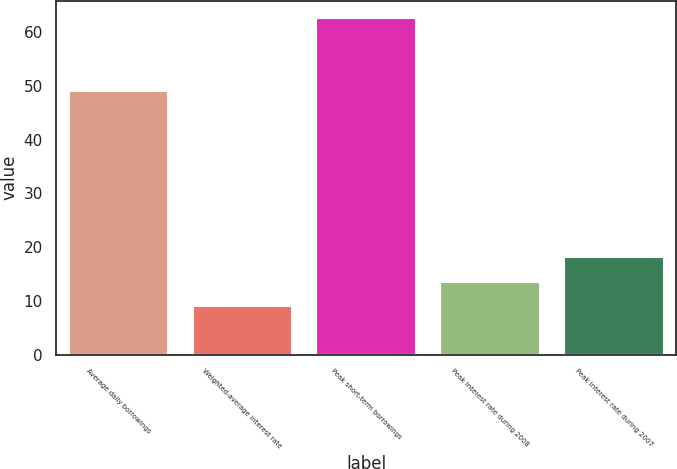<chart> <loc_0><loc_0><loc_500><loc_500><bar_chart><fcel>Average daily borrowings<fcel>Weighted-average interest rate<fcel>Peak short-term borrowings<fcel>Peak interest rate during 2008<fcel>Peak interest rate during 2007<nl><fcel>49<fcel>9.05<fcel>62.65<fcel>13.6<fcel>18.15<nl></chart> 